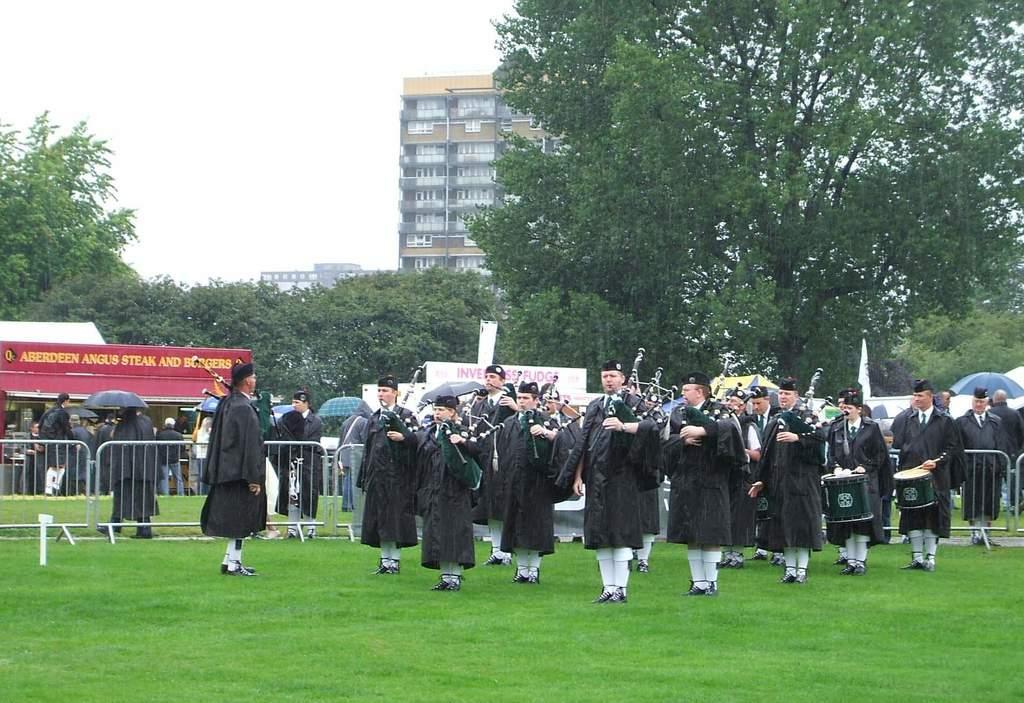Could you give a brief overview of what you see in this image? Here in this picture, in the front we can see number of people wearing a same kind of dress and standing on the ground, which is fully covered with grass and we can see they are playing bagpipes, flute and drums present with them and behind them we can see barricades present and we can see other people standing and walking on the ground over there and we can see some people are carrying umbrellas and we can also see some stores present and in the far we can see plants and trees covered and we can also see buildings present. 